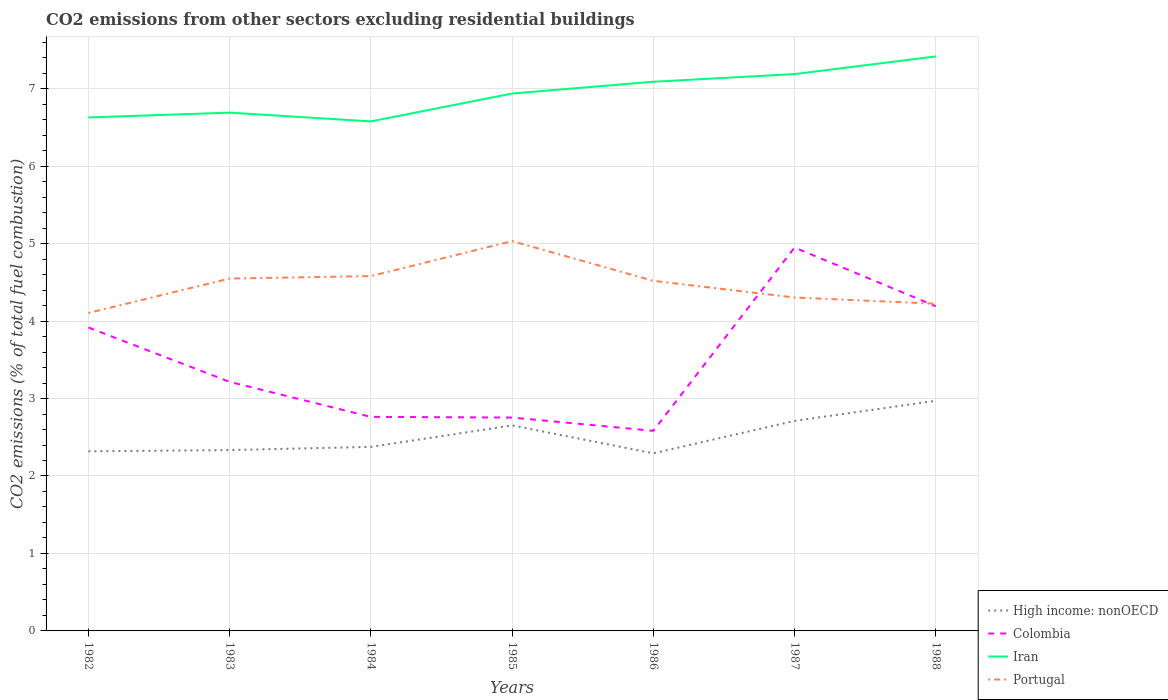How many different coloured lines are there?
Provide a short and direct response. 4. Across all years, what is the maximum total CO2 emitted in High income: nonOECD?
Provide a succinct answer. 2.29. What is the total total CO2 emitted in Colombia in the graph?
Your response must be concise. -1.44. What is the difference between the highest and the second highest total CO2 emitted in Portugal?
Your answer should be very brief. 0.93. Is the total CO2 emitted in Portugal strictly greater than the total CO2 emitted in High income: nonOECD over the years?
Provide a short and direct response. No. How many years are there in the graph?
Provide a succinct answer. 7. What is the difference between two consecutive major ticks on the Y-axis?
Give a very brief answer. 1. Are the values on the major ticks of Y-axis written in scientific E-notation?
Your response must be concise. No. Does the graph contain any zero values?
Keep it short and to the point. No. Does the graph contain grids?
Your answer should be compact. Yes. Where does the legend appear in the graph?
Make the answer very short. Bottom right. How many legend labels are there?
Provide a succinct answer. 4. What is the title of the graph?
Ensure brevity in your answer.  CO2 emissions from other sectors excluding residential buildings. What is the label or title of the Y-axis?
Provide a succinct answer. CO2 emissions (% of total fuel combustion). What is the CO2 emissions (% of total fuel combustion) of High income: nonOECD in 1982?
Keep it short and to the point. 2.32. What is the CO2 emissions (% of total fuel combustion) of Colombia in 1982?
Ensure brevity in your answer.  3.92. What is the CO2 emissions (% of total fuel combustion) in Iran in 1982?
Your response must be concise. 6.63. What is the CO2 emissions (% of total fuel combustion) in Portugal in 1982?
Your answer should be compact. 4.1. What is the CO2 emissions (% of total fuel combustion) in High income: nonOECD in 1983?
Your response must be concise. 2.33. What is the CO2 emissions (% of total fuel combustion) of Colombia in 1983?
Offer a terse response. 3.22. What is the CO2 emissions (% of total fuel combustion) in Iran in 1983?
Provide a succinct answer. 6.69. What is the CO2 emissions (% of total fuel combustion) of Portugal in 1983?
Your response must be concise. 4.55. What is the CO2 emissions (% of total fuel combustion) in High income: nonOECD in 1984?
Ensure brevity in your answer.  2.38. What is the CO2 emissions (% of total fuel combustion) of Colombia in 1984?
Ensure brevity in your answer.  2.76. What is the CO2 emissions (% of total fuel combustion) in Iran in 1984?
Provide a succinct answer. 6.58. What is the CO2 emissions (% of total fuel combustion) of Portugal in 1984?
Provide a short and direct response. 4.58. What is the CO2 emissions (% of total fuel combustion) in High income: nonOECD in 1985?
Your response must be concise. 2.65. What is the CO2 emissions (% of total fuel combustion) of Colombia in 1985?
Ensure brevity in your answer.  2.75. What is the CO2 emissions (% of total fuel combustion) of Iran in 1985?
Your response must be concise. 6.94. What is the CO2 emissions (% of total fuel combustion) in Portugal in 1985?
Make the answer very short. 5.03. What is the CO2 emissions (% of total fuel combustion) of High income: nonOECD in 1986?
Your answer should be compact. 2.29. What is the CO2 emissions (% of total fuel combustion) in Colombia in 1986?
Provide a short and direct response. 2.58. What is the CO2 emissions (% of total fuel combustion) in Iran in 1986?
Make the answer very short. 7.09. What is the CO2 emissions (% of total fuel combustion) in Portugal in 1986?
Offer a very short reply. 4.52. What is the CO2 emissions (% of total fuel combustion) in High income: nonOECD in 1987?
Offer a terse response. 2.71. What is the CO2 emissions (% of total fuel combustion) of Colombia in 1987?
Make the answer very short. 4.95. What is the CO2 emissions (% of total fuel combustion) in Iran in 1987?
Provide a succinct answer. 7.19. What is the CO2 emissions (% of total fuel combustion) of Portugal in 1987?
Give a very brief answer. 4.3. What is the CO2 emissions (% of total fuel combustion) of High income: nonOECD in 1988?
Your answer should be very brief. 2.97. What is the CO2 emissions (% of total fuel combustion) in Colombia in 1988?
Your answer should be compact. 4.19. What is the CO2 emissions (% of total fuel combustion) of Iran in 1988?
Your response must be concise. 7.42. What is the CO2 emissions (% of total fuel combustion) of Portugal in 1988?
Keep it short and to the point. 4.22. Across all years, what is the maximum CO2 emissions (% of total fuel combustion) in High income: nonOECD?
Make the answer very short. 2.97. Across all years, what is the maximum CO2 emissions (% of total fuel combustion) in Colombia?
Your answer should be compact. 4.95. Across all years, what is the maximum CO2 emissions (% of total fuel combustion) of Iran?
Your answer should be very brief. 7.42. Across all years, what is the maximum CO2 emissions (% of total fuel combustion) in Portugal?
Provide a short and direct response. 5.03. Across all years, what is the minimum CO2 emissions (% of total fuel combustion) of High income: nonOECD?
Your answer should be compact. 2.29. Across all years, what is the minimum CO2 emissions (% of total fuel combustion) of Colombia?
Your answer should be compact. 2.58. Across all years, what is the minimum CO2 emissions (% of total fuel combustion) of Iran?
Give a very brief answer. 6.58. Across all years, what is the minimum CO2 emissions (% of total fuel combustion) in Portugal?
Ensure brevity in your answer.  4.1. What is the total CO2 emissions (% of total fuel combustion) in High income: nonOECD in the graph?
Provide a short and direct response. 17.66. What is the total CO2 emissions (% of total fuel combustion) of Colombia in the graph?
Offer a very short reply. 24.37. What is the total CO2 emissions (% of total fuel combustion) of Iran in the graph?
Provide a succinct answer. 48.53. What is the total CO2 emissions (% of total fuel combustion) in Portugal in the graph?
Your response must be concise. 31.32. What is the difference between the CO2 emissions (% of total fuel combustion) of High income: nonOECD in 1982 and that in 1983?
Provide a succinct answer. -0.02. What is the difference between the CO2 emissions (% of total fuel combustion) of Colombia in 1982 and that in 1983?
Your answer should be very brief. 0.7. What is the difference between the CO2 emissions (% of total fuel combustion) in Iran in 1982 and that in 1983?
Provide a short and direct response. -0.06. What is the difference between the CO2 emissions (% of total fuel combustion) in Portugal in 1982 and that in 1983?
Provide a succinct answer. -0.44. What is the difference between the CO2 emissions (% of total fuel combustion) of High income: nonOECD in 1982 and that in 1984?
Offer a very short reply. -0.06. What is the difference between the CO2 emissions (% of total fuel combustion) of Colombia in 1982 and that in 1984?
Provide a short and direct response. 1.15. What is the difference between the CO2 emissions (% of total fuel combustion) of Iran in 1982 and that in 1984?
Your response must be concise. 0.05. What is the difference between the CO2 emissions (% of total fuel combustion) of Portugal in 1982 and that in 1984?
Your response must be concise. -0.48. What is the difference between the CO2 emissions (% of total fuel combustion) of High income: nonOECD in 1982 and that in 1985?
Your response must be concise. -0.33. What is the difference between the CO2 emissions (% of total fuel combustion) of Colombia in 1982 and that in 1985?
Your answer should be very brief. 1.16. What is the difference between the CO2 emissions (% of total fuel combustion) of Iran in 1982 and that in 1985?
Make the answer very short. -0.31. What is the difference between the CO2 emissions (% of total fuel combustion) in Portugal in 1982 and that in 1985?
Your answer should be compact. -0.93. What is the difference between the CO2 emissions (% of total fuel combustion) in High income: nonOECD in 1982 and that in 1986?
Your answer should be very brief. 0.03. What is the difference between the CO2 emissions (% of total fuel combustion) in Colombia in 1982 and that in 1986?
Provide a short and direct response. 1.33. What is the difference between the CO2 emissions (% of total fuel combustion) in Iran in 1982 and that in 1986?
Give a very brief answer. -0.46. What is the difference between the CO2 emissions (% of total fuel combustion) in Portugal in 1982 and that in 1986?
Offer a very short reply. -0.41. What is the difference between the CO2 emissions (% of total fuel combustion) of High income: nonOECD in 1982 and that in 1987?
Your answer should be compact. -0.39. What is the difference between the CO2 emissions (% of total fuel combustion) in Colombia in 1982 and that in 1987?
Offer a terse response. -1.03. What is the difference between the CO2 emissions (% of total fuel combustion) in Iran in 1982 and that in 1987?
Your response must be concise. -0.56. What is the difference between the CO2 emissions (% of total fuel combustion) in Portugal in 1982 and that in 1987?
Your response must be concise. -0.2. What is the difference between the CO2 emissions (% of total fuel combustion) in High income: nonOECD in 1982 and that in 1988?
Your answer should be compact. -0.65. What is the difference between the CO2 emissions (% of total fuel combustion) in Colombia in 1982 and that in 1988?
Ensure brevity in your answer.  -0.27. What is the difference between the CO2 emissions (% of total fuel combustion) of Iran in 1982 and that in 1988?
Offer a terse response. -0.79. What is the difference between the CO2 emissions (% of total fuel combustion) of Portugal in 1982 and that in 1988?
Your answer should be compact. -0.12. What is the difference between the CO2 emissions (% of total fuel combustion) in High income: nonOECD in 1983 and that in 1984?
Your response must be concise. -0.04. What is the difference between the CO2 emissions (% of total fuel combustion) in Colombia in 1983 and that in 1984?
Offer a terse response. 0.45. What is the difference between the CO2 emissions (% of total fuel combustion) in Iran in 1983 and that in 1984?
Your answer should be very brief. 0.11. What is the difference between the CO2 emissions (% of total fuel combustion) of Portugal in 1983 and that in 1984?
Make the answer very short. -0.03. What is the difference between the CO2 emissions (% of total fuel combustion) in High income: nonOECD in 1983 and that in 1985?
Your answer should be compact. -0.32. What is the difference between the CO2 emissions (% of total fuel combustion) of Colombia in 1983 and that in 1985?
Offer a very short reply. 0.46. What is the difference between the CO2 emissions (% of total fuel combustion) of Iran in 1983 and that in 1985?
Your answer should be very brief. -0.25. What is the difference between the CO2 emissions (% of total fuel combustion) of Portugal in 1983 and that in 1985?
Your answer should be compact. -0.48. What is the difference between the CO2 emissions (% of total fuel combustion) of High income: nonOECD in 1983 and that in 1986?
Offer a terse response. 0.04. What is the difference between the CO2 emissions (% of total fuel combustion) in Colombia in 1983 and that in 1986?
Your response must be concise. 0.63. What is the difference between the CO2 emissions (% of total fuel combustion) in Iran in 1983 and that in 1986?
Make the answer very short. -0.4. What is the difference between the CO2 emissions (% of total fuel combustion) of Portugal in 1983 and that in 1986?
Your response must be concise. 0.03. What is the difference between the CO2 emissions (% of total fuel combustion) in High income: nonOECD in 1983 and that in 1987?
Your response must be concise. -0.38. What is the difference between the CO2 emissions (% of total fuel combustion) of Colombia in 1983 and that in 1987?
Give a very brief answer. -1.73. What is the difference between the CO2 emissions (% of total fuel combustion) of Iran in 1983 and that in 1987?
Keep it short and to the point. -0.5. What is the difference between the CO2 emissions (% of total fuel combustion) in Portugal in 1983 and that in 1987?
Provide a succinct answer. 0.24. What is the difference between the CO2 emissions (% of total fuel combustion) of High income: nonOECD in 1983 and that in 1988?
Provide a succinct answer. -0.64. What is the difference between the CO2 emissions (% of total fuel combustion) of Colombia in 1983 and that in 1988?
Offer a very short reply. -0.98. What is the difference between the CO2 emissions (% of total fuel combustion) in Iran in 1983 and that in 1988?
Ensure brevity in your answer.  -0.73. What is the difference between the CO2 emissions (% of total fuel combustion) of Portugal in 1983 and that in 1988?
Offer a very short reply. 0.32. What is the difference between the CO2 emissions (% of total fuel combustion) of High income: nonOECD in 1984 and that in 1985?
Your response must be concise. -0.28. What is the difference between the CO2 emissions (% of total fuel combustion) of Colombia in 1984 and that in 1985?
Your answer should be very brief. 0.01. What is the difference between the CO2 emissions (% of total fuel combustion) in Iran in 1984 and that in 1985?
Your response must be concise. -0.36. What is the difference between the CO2 emissions (% of total fuel combustion) in Portugal in 1984 and that in 1985?
Ensure brevity in your answer.  -0.45. What is the difference between the CO2 emissions (% of total fuel combustion) of High income: nonOECD in 1984 and that in 1986?
Offer a very short reply. 0.08. What is the difference between the CO2 emissions (% of total fuel combustion) of Colombia in 1984 and that in 1986?
Your response must be concise. 0.18. What is the difference between the CO2 emissions (% of total fuel combustion) in Iran in 1984 and that in 1986?
Give a very brief answer. -0.51. What is the difference between the CO2 emissions (% of total fuel combustion) in Portugal in 1984 and that in 1986?
Provide a short and direct response. 0.06. What is the difference between the CO2 emissions (% of total fuel combustion) of High income: nonOECD in 1984 and that in 1987?
Provide a succinct answer. -0.34. What is the difference between the CO2 emissions (% of total fuel combustion) in Colombia in 1984 and that in 1987?
Offer a very short reply. -2.19. What is the difference between the CO2 emissions (% of total fuel combustion) in Iran in 1984 and that in 1987?
Your answer should be compact. -0.61. What is the difference between the CO2 emissions (% of total fuel combustion) in Portugal in 1984 and that in 1987?
Offer a very short reply. 0.28. What is the difference between the CO2 emissions (% of total fuel combustion) of High income: nonOECD in 1984 and that in 1988?
Make the answer very short. -0.59. What is the difference between the CO2 emissions (% of total fuel combustion) of Colombia in 1984 and that in 1988?
Your response must be concise. -1.43. What is the difference between the CO2 emissions (% of total fuel combustion) in Iran in 1984 and that in 1988?
Offer a very short reply. -0.84. What is the difference between the CO2 emissions (% of total fuel combustion) in Portugal in 1984 and that in 1988?
Give a very brief answer. 0.36. What is the difference between the CO2 emissions (% of total fuel combustion) in High income: nonOECD in 1985 and that in 1986?
Provide a short and direct response. 0.36. What is the difference between the CO2 emissions (% of total fuel combustion) in Colombia in 1985 and that in 1986?
Ensure brevity in your answer.  0.17. What is the difference between the CO2 emissions (% of total fuel combustion) of Iran in 1985 and that in 1986?
Ensure brevity in your answer.  -0.15. What is the difference between the CO2 emissions (% of total fuel combustion) of Portugal in 1985 and that in 1986?
Your response must be concise. 0.51. What is the difference between the CO2 emissions (% of total fuel combustion) in High income: nonOECD in 1985 and that in 1987?
Ensure brevity in your answer.  -0.06. What is the difference between the CO2 emissions (% of total fuel combustion) in Colombia in 1985 and that in 1987?
Your response must be concise. -2.19. What is the difference between the CO2 emissions (% of total fuel combustion) in Iran in 1985 and that in 1987?
Your response must be concise. -0.25. What is the difference between the CO2 emissions (% of total fuel combustion) in Portugal in 1985 and that in 1987?
Offer a very short reply. 0.73. What is the difference between the CO2 emissions (% of total fuel combustion) in High income: nonOECD in 1985 and that in 1988?
Make the answer very short. -0.32. What is the difference between the CO2 emissions (% of total fuel combustion) of Colombia in 1985 and that in 1988?
Your answer should be compact. -1.44. What is the difference between the CO2 emissions (% of total fuel combustion) of Iran in 1985 and that in 1988?
Provide a short and direct response. -0.48. What is the difference between the CO2 emissions (% of total fuel combustion) of Portugal in 1985 and that in 1988?
Provide a succinct answer. 0.81. What is the difference between the CO2 emissions (% of total fuel combustion) of High income: nonOECD in 1986 and that in 1987?
Provide a succinct answer. -0.42. What is the difference between the CO2 emissions (% of total fuel combustion) of Colombia in 1986 and that in 1987?
Make the answer very short. -2.37. What is the difference between the CO2 emissions (% of total fuel combustion) in Iran in 1986 and that in 1987?
Make the answer very short. -0.1. What is the difference between the CO2 emissions (% of total fuel combustion) of Portugal in 1986 and that in 1987?
Your answer should be very brief. 0.22. What is the difference between the CO2 emissions (% of total fuel combustion) in High income: nonOECD in 1986 and that in 1988?
Make the answer very short. -0.68. What is the difference between the CO2 emissions (% of total fuel combustion) of Colombia in 1986 and that in 1988?
Make the answer very short. -1.61. What is the difference between the CO2 emissions (% of total fuel combustion) of Iran in 1986 and that in 1988?
Your answer should be very brief. -0.33. What is the difference between the CO2 emissions (% of total fuel combustion) of Portugal in 1986 and that in 1988?
Give a very brief answer. 0.3. What is the difference between the CO2 emissions (% of total fuel combustion) in High income: nonOECD in 1987 and that in 1988?
Give a very brief answer. -0.26. What is the difference between the CO2 emissions (% of total fuel combustion) in Colombia in 1987 and that in 1988?
Offer a terse response. 0.76. What is the difference between the CO2 emissions (% of total fuel combustion) of Iran in 1987 and that in 1988?
Offer a very short reply. -0.23. What is the difference between the CO2 emissions (% of total fuel combustion) of Portugal in 1987 and that in 1988?
Offer a very short reply. 0.08. What is the difference between the CO2 emissions (% of total fuel combustion) of High income: nonOECD in 1982 and the CO2 emissions (% of total fuel combustion) of Colombia in 1983?
Ensure brevity in your answer.  -0.9. What is the difference between the CO2 emissions (% of total fuel combustion) in High income: nonOECD in 1982 and the CO2 emissions (% of total fuel combustion) in Iran in 1983?
Your answer should be very brief. -4.37. What is the difference between the CO2 emissions (% of total fuel combustion) of High income: nonOECD in 1982 and the CO2 emissions (% of total fuel combustion) of Portugal in 1983?
Provide a succinct answer. -2.23. What is the difference between the CO2 emissions (% of total fuel combustion) in Colombia in 1982 and the CO2 emissions (% of total fuel combustion) in Iran in 1983?
Offer a terse response. -2.77. What is the difference between the CO2 emissions (% of total fuel combustion) of Colombia in 1982 and the CO2 emissions (% of total fuel combustion) of Portugal in 1983?
Keep it short and to the point. -0.63. What is the difference between the CO2 emissions (% of total fuel combustion) of Iran in 1982 and the CO2 emissions (% of total fuel combustion) of Portugal in 1983?
Your answer should be very brief. 2.08. What is the difference between the CO2 emissions (% of total fuel combustion) in High income: nonOECD in 1982 and the CO2 emissions (% of total fuel combustion) in Colombia in 1984?
Your response must be concise. -0.44. What is the difference between the CO2 emissions (% of total fuel combustion) of High income: nonOECD in 1982 and the CO2 emissions (% of total fuel combustion) of Iran in 1984?
Your response must be concise. -4.26. What is the difference between the CO2 emissions (% of total fuel combustion) in High income: nonOECD in 1982 and the CO2 emissions (% of total fuel combustion) in Portugal in 1984?
Your answer should be compact. -2.26. What is the difference between the CO2 emissions (% of total fuel combustion) in Colombia in 1982 and the CO2 emissions (% of total fuel combustion) in Iran in 1984?
Offer a terse response. -2.66. What is the difference between the CO2 emissions (% of total fuel combustion) of Colombia in 1982 and the CO2 emissions (% of total fuel combustion) of Portugal in 1984?
Offer a terse response. -0.66. What is the difference between the CO2 emissions (% of total fuel combustion) of Iran in 1982 and the CO2 emissions (% of total fuel combustion) of Portugal in 1984?
Give a very brief answer. 2.05. What is the difference between the CO2 emissions (% of total fuel combustion) of High income: nonOECD in 1982 and the CO2 emissions (% of total fuel combustion) of Colombia in 1985?
Your answer should be compact. -0.44. What is the difference between the CO2 emissions (% of total fuel combustion) of High income: nonOECD in 1982 and the CO2 emissions (% of total fuel combustion) of Iran in 1985?
Keep it short and to the point. -4.62. What is the difference between the CO2 emissions (% of total fuel combustion) in High income: nonOECD in 1982 and the CO2 emissions (% of total fuel combustion) in Portugal in 1985?
Your answer should be very brief. -2.71. What is the difference between the CO2 emissions (% of total fuel combustion) in Colombia in 1982 and the CO2 emissions (% of total fuel combustion) in Iran in 1985?
Provide a succinct answer. -3.02. What is the difference between the CO2 emissions (% of total fuel combustion) of Colombia in 1982 and the CO2 emissions (% of total fuel combustion) of Portugal in 1985?
Your answer should be compact. -1.12. What is the difference between the CO2 emissions (% of total fuel combustion) of Iran in 1982 and the CO2 emissions (% of total fuel combustion) of Portugal in 1985?
Your answer should be very brief. 1.6. What is the difference between the CO2 emissions (% of total fuel combustion) in High income: nonOECD in 1982 and the CO2 emissions (% of total fuel combustion) in Colombia in 1986?
Ensure brevity in your answer.  -0.26. What is the difference between the CO2 emissions (% of total fuel combustion) in High income: nonOECD in 1982 and the CO2 emissions (% of total fuel combustion) in Iran in 1986?
Make the answer very short. -4.77. What is the difference between the CO2 emissions (% of total fuel combustion) of High income: nonOECD in 1982 and the CO2 emissions (% of total fuel combustion) of Portugal in 1986?
Your answer should be compact. -2.2. What is the difference between the CO2 emissions (% of total fuel combustion) of Colombia in 1982 and the CO2 emissions (% of total fuel combustion) of Iran in 1986?
Provide a short and direct response. -3.17. What is the difference between the CO2 emissions (% of total fuel combustion) in Colombia in 1982 and the CO2 emissions (% of total fuel combustion) in Portugal in 1986?
Provide a succinct answer. -0.6. What is the difference between the CO2 emissions (% of total fuel combustion) in Iran in 1982 and the CO2 emissions (% of total fuel combustion) in Portugal in 1986?
Your answer should be very brief. 2.11. What is the difference between the CO2 emissions (% of total fuel combustion) of High income: nonOECD in 1982 and the CO2 emissions (% of total fuel combustion) of Colombia in 1987?
Offer a very short reply. -2.63. What is the difference between the CO2 emissions (% of total fuel combustion) in High income: nonOECD in 1982 and the CO2 emissions (% of total fuel combustion) in Iran in 1987?
Make the answer very short. -4.87. What is the difference between the CO2 emissions (% of total fuel combustion) of High income: nonOECD in 1982 and the CO2 emissions (% of total fuel combustion) of Portugal in 1987?
Your response must be concise. -1.99. What is the difference between the CO2 emissions (% of total fuel combustion) in Colombia in 1982 and the CO2 emissions (% of total fuel combustion) in Iran in 1987?
Keep it short and to the point. -3.27. What is the difference between the CO2 emissions (% of total fuel combustion) in Colombia in 1982 and the CO2 emissions (% of total fuel combustion) in Portugal in 1987?
Your response must be concise. -0.39. What is the difference between the CO2 emissions (% of total fuel combustion) in Iran in 1982 and the CO2 emissions (% of total fuel combustion) in Portugal in 1987?
Ensure brevity in your answer.  2.32. What is the difference between the CO2 emissions (% of total fuel combustion) of High income: nonOECD in 1982 and the CO2 emissions (% of total fuel combustion) of Colombia in 1988?
Provide a succinct answer. -1.87. What is the difference between the CO2 emissions (% of total fuel combustion) of High income: nonOECD in 1982 and the CO2 emissions (% of total fuel combustion) of Iran in 1988?
Your answer should be very brief. -5.1. What is the difference between the CO2 emissions (% of total fuel combustion) of High income: nonOECD in 1982 and the CO2 emissions (% of total fuel combustion) of Portugal in 1988?
Offer a terse response. -1.91. What is the difference between the CO2 emissions (% of total fuel combustion) of Colombia in 1982 and the CO2 emissions (% of total fuel combustion) of Iran in 1988?
Your response must be concise. -3.5. What is the difference between the CO2 emissions (% of total fuel combustion) in Colombia in 1982 and the CO2 emissions (% of total fuel combustion) in Portugal in 1988?
Offer a terse response. -0.31. What is the difference between the CO2 emissions (% of total fuel combustion) in Iran in 1982 and the CO2 emissions (% of total fuel combustion) in Portugal in 1988?
Provide a short and direct response. 2.4. What is the difference between the CO2 emissions (% of total fuel combustion) in High income: nonOECD in 1983 and the CO2 emissions (% of total fuel combustion) in Colombia in 1984?
Provide a succinct answer. -0.43. What is the difference between the CO2 emissions (% of total fuel combustion) of High income: nonOECD in 1983 and the CO2 emissions (% of total fuel combustion) of Iran in 1984?
Ensure brevity in your answer.  -4.24. What is the difference between the CO2 emissions (% of total fuel combustion) of High income: nonOECD in 1983 and the CO2 emissions (% of total fuel combustion) of Portugal in 1984?
Provide a short and direct response. -2.25. What is the difference between the CO2 emissions (% of total fuel combustion) of Colombia in 1983 and the CO2 emissions (% of total fuel combustion) of Iran in 1984?
Offer a very short reply. -3.36. What is the difference between the CO2 emissions (% of total fuel combustion) of Colombia in 1983 and the CO2 emissions (% of total fuel combustion) of Portugal in 1984?
Provide a short and direct response. -1.37. What is the difference between the CO2 emissions (% of total fuel combustion) in Iran in 1983 and the CO2 emissions (% of total fuel combustion) in Portugal in 1984?
Keep it short and to the point. 2.11. What is the difference between the CO2 emissions (% of total fuel combustion) in High income: nonOECD in 1983 and the CO2 emissions (% of total fuel combustion) in Colombia in 1985?
Your response must be concise. -0.42. What is the difference between the CO2 emissions (% of total fuel combustion) in High income: nonOECD in 1983 and the CO2 emissions (% of total fuel combustion) in Iran in 1985?
Make the answer very short. -4.6. What is the difference between the CO2 emissions (% of total fuel combustion) of High income: nonOECD in 1983 and the CO2 emissions (% of total fuel combustion) of Portugal in 1985?
Make the answer very short. -2.7. What is the difference between the CO2 emissions (% of total fuel combustion) of Colombia in 1983 and the CO2 emissions (% of total fuel combustion) of Iran in 1985?
Provide a succinct answer. -3.72. What is the difference between the CO2 emissions (% of total fuel combustion) of Colombia in 1983 and the CO2 emissions (% of total fuel combustion) of Portugal in 1985?
Give a very brief answer. -1.82. What is the difference between the CO2 emissions (% of total fuel combustion) in Iran in 1983 and the CO2 emissions (% of total fuel combustion) in Portugal in 1985?
Keep it short and to the point. 1.66. What is the difference between the CO2 emissions (% of total fuel combustion) in High income: nonOECD in 1983 and the CO2 emissions (% of total fuel combustion) in Colombia in 1986?
Ensure brevity in your answer.  -0.25. What is the difference between the CO2 emissions (% of total fuel combustion) in High income: nonOECD in 1983 and the CO2 emissions (% of total fuel combustion) in Iran in 1986?
Your answer should be very brief. -4.76. What is the difference between the CO2 emissions (% of total fuel combustion) in High income: nonOECD in 1983 and the CO2 emissions (% of total fuel combustion) in Portugal in 1986?
Your answer should be compact. -2.19. What is the difference between the CO2 emissions (% of total fuel combustion) of Colombia in 1983 and the CO2 emissions (% of total fuel combustion) of Iran in 1986?
Give a very brief answer. -3.87. What is the difference between the CO2 emissions (% of total fuel combustion) of Colombia in 1983 and the CO2 emissions (% of total fuel combustion) of Portugal in 1986?
Offer a very short reply. -1.3. What is the difference between the CO2 emissions (% of total fuel combustion) of Iran in 1983 and the CO2 emissions (% of total fuel combustion) of Portugal in 1986?
Your answer should be very brief. 2.17. What is the difference between the CO2 emissions (% of total fuel combustion) in High income: nonOECD in 1983 and the CO2 emissions (% of total fuel combustion) in Colombia in 1987?
Your response must be concise. -2.62. What is the difference between the CO2 emissions (% of total fuel combustion) in High income: nonOECD in 1983 and the CO2 emissions (% of total fuel combustion) in Iran in 1987?
Make the answer very short. -4.85. What is the difference between the CO2 emissions (% of total fuel combustion) in High income: nonOECD in 1983 and the CO2 emissions (% of total fuel combustion) in Portugal in 1987?
Make the answer very short. -1.97. What is the difference between the CO2 emissions (% of total fuel combustion) in Colombia in 1983 and the CO2 emissions (% of total fuel combustion) in Iran in 1987?
Your response must be concise. -3.97. What is the difference between the CO2 emissions (% of total fuel combustion) in Colombia in 1983 and the CO2 emissions (% of total fuel combustion) in Portugal in 1987?
Your response must be concise. -1.09. What is the difference between the CO2 emissions (% of total fuel combustion) of Iran in 1983 and the CO2 emissions (% of total fuel combustion) of Portugal in 1987?
Offer a terse response. 2.39. What is the difference between the CO2 emissions (% of total fuel combustion) in High income: nonOECD in 1983 and the CO2 emissions (% of total fuel combustion) in Colombia in 1988?
Make the answer very short. -1.86. What is the difference between the CO2 emissions (% of total fuel combustion) of High income: nonOECD in 1983 and the CO2 emissions (% of total fuel combustion) of Iran in 1988?
Provide a succinct answer. -5.08. What is the difference between the CO2 emissions (% of total fuel combustion) of High income: nonOECD in 1983 and the CO2 emissions (% of total fuel combustion) of Portugal in 1988?
Offer a terse response. -1.89. What is the difference between the CO2 emissions (% of total fuel combustion) in Colombia in 1983 and the CO2 emissions (% of total fuel combustion) in Iran in 1988?
Offer a very short reply. -4.2. What is the difference between the CO2 emissions (% of total fuel combustion) in Colombia in 1983 and the CO2 emissions (% of total fuel combustion) in Portugal in 1988?
Keep it short and to the point. -1.01. What is the difference between the CO2 emissions (% of total fuel combustion) of Iran in 1983 and the CO2 emissions (% of total fuel combustion) of Portugal in 1988?
Provide a succinct answer. 2.47. What is the difference between the CO2 emissions (% of total fuel combustion) of High income: nonOECD in 1984 and the CO2 emissions (% of total fuel combustion) of Colombia in 1985?
Your response must be concise. -0.38. What is the difference between the CO2 emissions (% of total fuel combustion) of High income: nonOECD in 1984 and the CO2 emissions (% of total fuel combustion) of Iran in 1985?
Offer a terse response. -4.56. What is the difference between the CO2 emissions (% of total fuel combustion) of High income: nonOECD in 1984 and the CO2 emissions (% of total fuel combustion) of Portugal in 1985?
Give a very brief answer. -2.66. What is the difference between the CO2 emissions (% of total fuel combustion) of Colombia in 1984 and the CO2 emissions (% of total fuel combustion) of Iran in 1985?
Your response must be concise. -4.17. What is the difference between the CO2 emissions (% of total fuel combustion) in Colombia in 1984 and the CO2 emissions (% of total fuel combustion) in Portugal in 1985?
Your answer should be very brief. -2.27. What is the difference between the CO2 emissions (% of total fuel combustion) of Iran in 1984 and the CO2 emissions (% of total fuel combustion) of Portugal in 1985?
Offer a terse response. 1.55. What is the difference between the CO2 emissions (% of total fuel combustion) in High income: nonOECD in 1984 and the CO2 emissions (% of total fuel combustion) in Colombia in 1986?
Your response must be concise. -0.21. What is the difference between the CO2 emissions (% of total fuel combustion) in High income: nonOECD in 1984 and the CO2 emissions (% of total fuel combustion) in Iran in 1986?
Provide a short and direct response. -4.71. What is the difference between the CO2 emissions (% of total fuel combustion) in High income: nonOECD in 1984 and the CO2 emissions (% of total fuel combustion) in Portugal in 1986?
Give a very brief answer. -2.14. What is the difference between the CO2 emissions (% of total fuel combustion) in Colombia in 1984 and the CO2 emissions (% of total fuel combustion) in Iran in 1986?
Ensure brevity in your answer.  -4.33. What is the difference between the CO2 emissions (% of total fuel combustion) in Colombia in 1984 and the CO2 emissions (% of total fuel combustion) in Portugal in 1986?
Make the answer very short. -1.76. What is the difference between the CO2 emissions (% of total fuel combustion) of Iran in 1984 and the CO2 emissions (% of total fuel combustion) of Portugal in 1986?
Your answer should be very brief. 2.06. What is the difference between the CO2 emissions (% of total fuel combustion) in High income: nonOECD in 1984 and the CO2 emissions (% of total fuel combustion) in Colombia in 1987?
Your answer should be very brief. -2.57. What is the difference between the CO2 emissions (% of total fuel combustion) of High income: nonOECD in 1984 and the CO2 emissions (% of total fuel combustion) of Iran in 1987?
Your response must be concise. -4.81. What is the difference between the CO2 emissions (% of total fuel combustion) of High income: nonOECD in 1984 and the CO2 emissions (% of total fuel combustion) of Portugal in 1987?
Provide a succinct answer. -1.93. What is the difference between the CO2 emissions (% of total fuel combustion) of Colombia in 1984 and the CO2 emissions (% of total fuel combustion) of Iran in 1987?
Your response must be concise. -4.43. What is the difference between the CO2 emissions (% of total fuel combustion) of Colombia in 1984 and the CO2 emissions (% of total fuel combustion) of Portugal in 1987?
Keep it short and to the point. -1.54. What is the difference between the CO2 emissions (% of total fuel combustion) of Iran in 1984 and the CO2 emissions (% of total fuel combustion) of Portugal in 1987?
Your response must be concise. 2.27. What is the difference between the CO2 emissions (% of total fuel combustion) of High income: nonOECD in 1984 and the CO2 emissions (% of total fuel combustion) of Colombia in 1988?
Keep it short and to the point. -1.82. What is the difference between the CO2 emissions (% of total fuel combustion) in High income: nonOECD in 1984 and the CO2 emissions (% of total fuel combustion) in Iran in 1988?
Your answer should be compact. -5.04. What is the difference between the CO2 emissions (% of total fuel combustion) of High income: nonOECD in 1984 and the CO2 emissions (% of total fuel combustion) of Portugal in 1988?
Your answer should be very brief. -1.85. What is the difference between the CO2 emissions (% of total fuel combustion) of Colombia in 1984 and the CO2 emissions (% of total fuel combustion) of Iran in 1988?
Offer a terse response. -4.65. What is the difference between the CO2 emissions (% of total fuel combustion) of Colombia in 1984 and the CO2 emissions (% of total fuel combustion) of Portugal in 1988?
Offer a very short reply. -1.46. What is the difference between the CO2 emissions (% of total fuel combustion) of Iran in 1984 and the CO2 emissions (% of total fuel combustion) of Portugal in 1988?
Your answer should be very brief. 2.35. What is the difference between the CO2 emissions (% of total fuel combustion) in High income: nonOECD in 1985 and the CO2 emissions (% of total fuel combustion) in Colombia in 1986?
Ensure brevity in your answer.  0.07. What is the difference between the CO2 emissions (% of total fuel combustion) of High income: nonOECD in 1985 and the CO2 emissions (% of total fuel combustion) of Iran in 1986?
Provide a short and direct response. -4.44. What is the difference between the CO2 emissions (% of total fuel combustion) of High income: nonOECD in 1985 and the CO2 emissions (% of total fuel combustion) of Portugal in 1986?
Your response must be concise. -1.87. What is the difference between the CO2 emissions (% of total fuel combustion) in Colombia in 1985 and the CO2 emissions (% of total fuel combustion) in Iran in 1986?
Offer a very short reply. -4.34. What is the difference between the CO2 emissions (% of total fuel combustion) of Colombia in 1985 and the CO2 emissions (% of total fuel combustion) of Portugal in 1986?
Keep it short and to the point. -1.76. What is the difference between the CO2 emissions (% of total fuel combustion) in Iran in 1985 and the CO2 emissions (% of total fuel combustion) in Portugal in 1986?
Ensure brevity in your answer.  2.42. What is the difference between the CO2 emissions (% of total fuel combustion) in High income: nonOECD in 1985 and the CO2 emissions (% of total fuel combustion) in Colombia in 1987?
Offer a very short reply. -2.3. What is the difference between the CO2 emissions (% of total fuel combustion) in High income: nonOECD in 1985 and the CO2 emissions (% of total fuel combustion) in Iran in 1987?
Offer a very short reply. -4.54. What is the difference between the CO2 emissions (% of total fuel combustion) of High income: nonOECD in 1985 and the CO2 emissions (% of total fuel combustion) of Portugal in 1987?
Your answer should be compact. -1.65. What is the difference between the CO2 emissions (% of total fuel combustion) of Colombia in 1985 and the CO2 emissions (% of total fuel combustion) of Iran in 1987?
Offer a very short reply. -4.43. What is the difference between the CO2 emissions (% of total fuel combustion) of Colombia in 1985 and the CO2 emissions (% of total fuel combustion) of Portugal in 1987?
Make the answer very short. -1.55. What is the difference between the CO2 emissions (% of total fuel combustion) in Iran in 1985 and the CO2 emissions (% of total fuel combustion) in Portugal in 1987?
Ensure brevity in your answer.  2.63. What is the difference between the CO2 emissions (% of total fuel combustion) in High income: nonOECD in 1985 and the CO2 emissions (% of total fuel combustion) in Colombia in 1988?
Make the answer very short. -1.54. What is the difference between the CO2 emissions (% of total fuel combustion) in High income: nonOECD in 1985 and the CO2 emissions (% of total fuel combustion) in Iran in 1988?
Your response must be concise. -4.76. What is the difference between the CO2 emissions (% of total fuel combustion) in High income: nonOECD in 1985 and the CO2 emissions (% of total fuel combustion) in Portugal in 1988?
Your answer should be compact. -1.57. What is the difference between the CO2 emissions (% of total fuel combustion) of Colombia in 1985 and the CO2 emissions (% of total fuel combustion) of Iran in 1988?
Your response must be concise. -4.66. What is the difference between the CO2 emissions (% of total fuel combustion) in Colombia in 1985 and the CO2 emissions (% of total fuel combustion) in Portugal in 1988?
Your answer should be very brief. -1.47. What is the difference between the CO2 emissions (% of total fuel combustion) of Iran in 1985 and the CO2 emissions (% of total fuel combustion) of Portugal in 1988?
Provide a short and direct response. 2.71. What is the difference between the CO2 emissions (% of total fuel combustion) of High income: nonOECD in 1986 and the CO2 emissions (% of total fuel combustion) of Colombia in 1987?
Provide a succinct answer. -2.66. What is the difference between the CO2 emissions (% of total fuel combustion) of High income: nonOECD in 1986 and the CO2 emissions (% of total fuel combustion) of Iran in 1987?
Give a very brief answer. -4.9. What is the difference between the CO2 emissions (% of total fuel combustion) of High income: nonOECD in 1986 and the CO2 emissions (% of total fuel combustion) of Portugal in 1987?
Your answer should be compact. -2.01. What is the difference between the CO2 emissions (% of total fuel combustion) of Colombia in 1986 and the CO2 emissions (% of total fuel combustion) of Iran in 1987?
Provide a succinct answer. -4.61. What is the difference between the CO2 emissions (% of total fuel combustion) of Colombia in 1986 and the CO2 emissions (% of total fuel combustion) of Portugal in 1987?
Your response must be concise. -1.72. What is the difference between the CO2 emissions (% of total fuel combustion) in Iran in 1986 and the CO2 emissions (% of total fuel combustion) in Portugal in 1987?
Your answer should be compact. 2.79. What is the difference between the CO2 emissions (% of total fuel combustion) in High income: nonOECD in 1986 and the CO2 emissions (% of total fuel combustion) in Colombia in 1988?
Keep it short and to the point. -1.9. What is the difference between the CO2 emissions (% of total fuel combustion) of High income: nonOECD in 1986 and the CO2 emissions (% of total fuel combustion) of Iran in 1988?
Your answer should be very brief. -5.12. What is the difference between the CO2 emissions (% of total fuel combustion) of High income: nonOECD in 1986 and the CO2 emissions (% of total fuel combustion) of Portugal in 1988?
Your answer should be very brief. -1.93. What is the difference between the CO2 emissions (% of total fuel combustion) in Colombia in 1986 and the CO2 emissions (% of total fuel combustion) in Iran in 1988?
Provide a short and direct response. -4.83. What is the difference between the CO2 emissions (% of total fuel combustion) in Colombia in 1986 and the CO2 emissions (% of total fuel combustion) in Portugal in 1988?
Your answer should be compact. -1.64. What is the difference between the CO2 emissions (% of total fuel combustion) in Iran in 1986 and the CO2 emissions (% of total fuel combustion) in Portugal in 1988?
Your answer should be very brief. 2.87. What is the difference between the CO2 emissions (% of total fuel combustion) of High income: nonOECD in 1987 and the CO2 emissions (% of total fuel combustion) of Colombia in 1988?
Give a very brief answer. -1.48. What is the difference between the CO2 emissions (% of total fuel combustion) in High income: nonOECD in 1987 and the CO2 emissions (% of total fuel combustion) in Iran in 1988?
Give a very brief answer. -4.71. What is the difference between the CO2 emissions (% of total fuel combustion) of High income: nonOECD in 1987 and the CO2 emissions (% of total fuel combustion) of Portugal in 1988?
Provide a short and direct response. -1.51. What is the difference between the CO2 emissions (% of total fuel combustion) of Colombia in 1987 and the CO2 emissions (% of total fuel combustion) of Iran in 1988?
Provide a succinct answer. -2.47. What is the difference between the CO2 emissions (% of total fuel combustion) of Colombia in 1987 and the CO2 emissions (% of total fuel combustion) of Portugal in 1988?
Your answer should be compact. 0.73. What is the difference between the CO2 emissions (% of total fuel combustion) in Iran in 1987 and the CO2 emissions (% of total fuel combustion) in Portugal in 1988?
Your response must be concise. 2.96. What is the average CO2 emissions (% of total fuel combustion) in High income: nonOECD per year?
Your answer should be compact. 2.52. What is the average CO2 emissions (% of total fuel combustion) in Colombia per year?
Offer a terse response. 3.48. What is the average CO2 emissions (% of total fuel combustion) of Iran per year?
Provide a short and direct response. 6.93. What is the average CO2 emissions (% of total fuel combustion) in Portugal per year?
Your answer should be very brief. 4.47. In the year 1982, what is the difference between the CO2 emissions (% of total fuel combustion) in High income: nonOECD and CO2 emissions (% of total fuel combustion) in Colombia?
Provide a succinct answer. -1.6. In the year 1982, what is the difference between the CO2 emissions (% of total fuel combustion) of High income: nonOECD and CO2 emissions (% of total fuel combustion) of Iran?
Your response must be concise. -4.31. In the year 1982, what is the difference between the CO2 emissions (% of total fuel combustion) of High income: nonOECD and CO2 emissions (% of total fuel combustion) of Portugal?
Offer a terse response. -1.79. In the year 1982, what is the difference between the CO2 emissions (% of total fuel combustion) in Colombia and CO2 emissions (% of total fuel combustion) in Iran?
Keep it short and to the point. -2.71. In the year 1982, what is the difference between the CO2 emissions (% of total fuel combustion) of Colombia and CO2 emissions (% of total fuel combustion) of Portugal?
Keep it short and to the point. -0.19. In the year 1982, what is the difference between the CO2 emissions (% of total fuel combustion) of Iran and CO2 emissions (% of total fuel combustion) of Portugal?
Keep it short and to the point. 2.52. In the year 1983, what is the difference between the CO2 emissions (% of total fuel combustion) of High income: nonOECD and CO2 emissions (% of total fuel combustion) of Colombia?
Provide a succinct answer. -0.88. In the year 1983, what is the difference between the CO2 emissions (% of total fuel combustion) in High income: nonOECD and CO2 emissions (% of total fuel combustion) in Iran?
Offer a very short reply. -4.36. In the year 1983, what is the difference between the CO2 emissions (% of total fuel combustion) of High income: nonOECD and CO2 emissions (% of total fuel combustion) of Portugal?
Your answer should be compact. -2.21. In the year 1983, what is the difference between the CO2 emissions (% of total fuel combustion) in Colombia and CO2 emissions (% of total fuel combustion) in Iran?
Keep it short and to the point. -3.48. In the year 1983, what is the difference between the CO2 emissions (% of total fuel combustion) in Colombia and CO2 emissions (% of total fuel combustion) in Portugal?
Provide a short and direct response. -1.33. In the year 1983, what is the difference between the CO2 emissions (% of total fuel combustion) in Iran and CO2 emissions (% of total fuel combustion) in Portugal?
Provide a succinct answer. 2.14. In the year 1984, what is the difference between the CO2 emissions (% of total fuel combustion) in High income: nonOECD and CO2 emissions (% of total fuel combustion) in Colombia?
Your answer should be compact. -0.39. In the year 1984, what is the difference between the CO2 emissions (% of total fuel combustion) in High income: nonOECD and CO2 emissions (% of total fuel combustion) in Iran?
Give a very brief answer. -4.2. In the year 1984, what is the difference between the CO2 emissions (% of total fuel combustion) of High income: nonOECD and CO2 emissions (% of total fuel combustion) of Portugal?
Offer a terse response. -2.2. In the year 1984, what is the difference between the CO2 emissions (% of total fuel combustion) in Colombia and CO2 emissions (% of total fuel combustion) in Iran?
Give a very brief answer. -3.81. In the year 1984, what is the difference between the CO2 emissions (% of total fuel combustion) of Colombia and CO2 emissions (% of total fuel combustion) of Portugal?
Make the answer very short. -1.82. In the year 1984, what is the difference between the CO2 emissions (% of total fuel combustion) of Iran and CO2 emissions (% of total fuel combustion) of Portugal?
Offer a very short reply. 2. In the year 1985, what is the difference between the CO2 emissions (% of total fuel combustion) in High income: nonOECD and CO2 emissions (% of total fuel combustion) in Colombia?
Your response must be concise. -0.1. In the year 1985, what is the difference between the CO2 emissions (% of total fuel combustion) in High income: nonOECD and CO2 emissions (% of total fuel combustion) in Iran?
Keep it short and to the point. -4.28. In the year 1985, what is the difference between the CO2 emissions (% of total fuel combustion) in High income: nonOECD and CO2 emissions (% of total fuel combustion) in Portugal?
Your response must be concise. -2.38. In the year 1985, what is the difference between the CO2 emissions (% of total fuel combustion) of Colombia and CO2 emissions (% of total fuel combustion) of Iran?
Your answer should be very brief. -4.18. In the year 1985, what is the difference between the CO2 emissions (% of total fuel combustion) of Colombia and CO2 emissions (% of total fuel combustion) of Portugal?
Provide a succinct answer. -2.28. In the year 1985, what is the difference between the CO2 emissions (% of total fuel combustion) in Iran and CO2 emissions (% of total fuel combustion) in Portugal?
Offer a terse response. 1.91. In the year 1986, what is the difference between the CO2 emissions (% of total fuel combustion) in High income: nonOECD and CO2 emissions (% of total fuel combustion) in Colombia?
Provide a short and direct response. -0.29. In the year 1986, what is the difference between the CO2 emissions (% of total fuel combustion) of High income: nonOECD and CO2 emissions (% of total fuel combustion) of Iran?
Your response must be concise. -4.8. In the year 1986, what is the difference between the CO2 emissions (% of total fuel combustion) of High income: nonOECD and CO2 emissions (% of total fuel combustion) of Portugal?
Offer a very short reply. -2.23. In the year 1986, what is the difference between the CO2 emissions (% of total fuel combustion) in Colombia and CO2 emissions (% of total fuel combustion) in Iran?
Your answer should be compact. -4.51. In the year 1986, what is the difference between the CO2 emissions (% of total fuel combustion) of Colombia and CO2 emissions (% of total fuel combustion) of Portugal?
Your answer should be very brief. -1.94. In the year 1986, what is the difference between the CO2 emissions (% of total fuel combustion) of Iran and CO2 emissions (% of total fuel combustion) of Portugal?
Ensure brevity in your answer.  2.57. In the year 1987, what is the difference between the CO2 emissions (% of total fuel combustion) in High income: nonOECD and CO2 emissions (% of total fuel combustion) in Colombia?
Keep it short and to the point. -2.24. In the year 1987, what is the difference between the CO2 emissions (% of total fuel combustion) in High income: nonOECD and CO2 emissions (% of total fuel combustion) in Iran?
Offer a very short reply. -4.48. In the year 1987, what is the difference between the CO2 emissions (% of total fuel combustion) of High income: nonOECD and CO2 emissions (% of total fuel combustion) of Portugal?
Ensure brevity in your answer.  -1.59. In the year 1987, what is the difference between the CO2 emissions (% of total fuel combustion) in Colombia and CO2 emissions (% of total fuel combustion) in Iran?
Offer a very short reply. -2.24. In the year 1987, what is the difference between the CO2 emissions (% of total fuel combustion) of Colombia and CO2 emissions (% of total fuel combustion) of Portugal?
Your answer should be compact. 0.65. In the year 1987, what is the difference between the CO2 emissions (% of total fuel combustion) of Iran and CO2 emissions (% of total fuel combustion) of Portugal?
Make the answer very short. 2.88. In the year 1988, what is the difference between the CO2 emissions (% of total fuel combustion) of High income: nonOECD and CO2 emissions (% of total fuel combustion) of Colombia?
Keep it short and to the point. -1.22. In the year 1988, what is the difference between the CO2 emissions (% of total fuel combustion) in High income: nonOECD and CO2 emissions (% of total fuel combustion) in Iran?
Give a very brief answer. -4.45. In the year 1988, what is the difference between the CO2 emissions (% of total fuel combustion) of High income: nonOECD and CO2 emissions (% of total fuel combustion) of Portugal?
Provide a short and direct response. -1.25. In the year 1988, what is the difference between the CO2 emissions (% of total fuel combustion) in Colombia and CO2 emissions (% of total fuel combustion) in Iran?
Make the answer very short. -3.23. In the year 1988, what is the difference between the CO2 emissions (% of total fuel combustion) of Colombia and CO2 emissions (% of total fuel combustion) of Portugal?
Ensure brevity in your answer.  -0.03. In the year 1988, what is the difference between the CO2 emissions (% of total fuel combustion) of Iran and CO2 emissions (% of total fuel combustion) of Portugal?
Offer a very short reply. 3.19. What is the ratio of the CO2 emissions (% of total fuel combustion) of Colombia in 1982 to that in 1983?
Offer a very short reply. 1.22. What is the ratio of the CO2 emissions (% of total fuel combustion) in Portugal in 1982 to that in 1983?
Your answer should be very brief. 0.9. What is the ratio of the CO2 emissions (% of total fuel combustion) in High income: nonOECD in 1982 to that in 1984?
Your answer should be compact. 0.98. What is the ratio of the CO2 emissions (% of total fuel combustion) in Colombia in 1982 to that in 1984?
Make the answer very short. 1.42. What is the ratio of the CO2 emissions (% of total fuel combustion) of Portugal in 1982 to that in 1984?
Ensure brevity in your answer.  0.9. What is the ratio of the CO2 emissions (% of total fuel combustion) of High income: nonOECD in 1982 to that in 1985?
Your response must be concise. 0.87. What is the ratio of the CO2 emissions (% of total fuel combustion) of Colombia in 1982 to that in 1985?
Make the answer very short. 1.42. What is the ratio of the CO2 emissions (% of total fuel combustion) in Iran in 1982 to that in 1985?
Give a very brief answer. 0.96. What is the ratio of the CO2 emissions (% of total fuel combustion) in Portugal in 1982 to that in 1985?
Offer a terse response. 0.82. What is the ratio of the CO2 emissions (% of total fuel combustion) in High income: nonOECD in 1982 to that in 1986?
Offer a very short reply. 1.01. What is the ratio of the CO2 emissions (% of total fuel combustion) of Colombia in 1982 to that in 1986?
Keep it short and to the point. 1.52. What is the ratio of the CO2 emissions (% of total fuel combustion) in Iran in 1982 to that in 1986?
Ensure brevity in your answer.  0.94. What is the ratio of the CO2 emissions (% of total fuel combustion) of Portugal in 1982 to that in 1986?
Your response must be concise. 0.91. What is the ratio of the CO2 emissions (% of total fuel combustion) of High income: nonOECD in 1982 to that in 1987?
Make the answer very short. 0.86. What is the ratio of the CO2 emissions (% of total fuel combustion) in Colombia in 1982 to that in 1987?
Provide a short and direct response. 0.79. What is the ratio of the CO2 emissions (% of total fuel combustion) in Iran in 1982 to that in 1987?
Make the answer very short. 0.92. What is the ratio of the CO2 emissions (% of total fuel combustion) in Portugal in 1982 to that in 1987?
Make the answer very short. 0.95. What is the ratio of the CO2 emissions (% of total fuel combustion) in High income: nonOECD in 1982 to that in 1988?
Your answer should be compact. 0.78. What is the ratio of the CO2 emissions (% of total fuel combustion) in Colombia in 1982 to that in 1988?
Your response must be concise. 0.93. What is the ratio of the CO2 emissions (% of total fuel combustion) of Iran in 1982 to that in 1988?
Keep it short and to the point. 0.89. What is the ratio of the CO2 emissions (% of total fuel combustion) in Portugal in 1982 to that in 1988?
Give a very brief answer. 0.97. What is the ratio of the CO2 emissions (% of total fuel combustion) of High income: nonOECD in 1983 to that in 1984?
Offer a very short reply. 0.98. What is the ratio of the CO2 emissions (% of total fuel combustion) of Colombia in 1983 to that in 1984?
Give a very brief answer. 1.16. What is the ratio of the CO2 emissions (% of total fuel combustion) in Iran in 1983 to that in 1984?
Provide a succinct answer. 1.02. What is the ratio of the CO2 emissions (% of total fuel combustion) in Portugal in 1983 to that in 1984?
Make the answer very short. 0.99. What is the ratio of the CO2 emissions (% of total fuel combustion) of Colombia in 1983 to that in 1985?
Ensure brevity in your answer.  1.17. What is the ratio of the CO2 emissions (% of total fuel combustion) of Iran in 1983 to that in 1985?
Your answer should be very brief. 0.96. What is the ratio of the CO2 emissions (% of total fuel combustion) in Portugal in 1983 to that in 1985?
Give a very brief answer. 0.9. What is the ratio of the CO2 emissions (% of total fuel combustion) of High income: nonOECD in 1983 to that in 1986?
Provide a succinct answer. 1.02. What is the ratio of the CO2 emissions (% of total fuel combustion) of Colombia in 1983 to that in 1986?
Give a very brief answer. 1.24. What is the ratio of the CO2 emissions (% of total fuel combustion) in Iran in 1983 to that in 1986?
Give a very brief answer. 0.94. What is the ratio of the CO2 emissions (% of total fuel combustion) of High income: nonOECD in 1983 to that in 1987?
Give a very brief answer. 0.86. What is the ratio of the CO2 emissions (% of total fuel combustion) of Colombia in 1983 to that in 1987?
Your response must be concise. 0.65. What is the ratio of the CO2 emissions (% of total fuel combustion) of Iran in 1983 to that in 1987?
Your answer should be compact. 0.93. What is the ratio of the CO2 emissions (% of total fuel combustion) in Portugal in 1983 to that in 1987?
Ensure brevity in your answer.  1.06. What is the ratio of the CO2 emissions (% of total fuel combustion) in High income: nonOECD in 1983 to that in 1988?
Your answer should be very brief. 0.79. What is the ratio of the CO2 emissions (% of total fuel combustion) of Colombia in 1983 to that in 1988?
Make the answer very short. 0.77. What is the ratio of the CO2 emissions (% of total fuel combustion) in Iran in 1983 to that in 1988?
Provide a short and direct response. 0.9. What is the ratio of the CO2 emissions (% of total fuel combustion) in Portugal in 1983 to that in 1988?
Give a very brief answer. 1.08. What is the ratio of the CO2 emissions (% of total fuel combustion) in High income: nonOECD in 1984 to that in 1985?
Your answer should be compact. 0.9. What is the ratio of the CO2 emissions (% of total fuel combustion) in Iran in 1984 to that in 1985?
Provide a succinct answer. 0.95. What is the ratio of the CO2 emissions (% of total fuel combustion) in Portugal in 1984 to that in 1985?
Give a very brief answer. 0.91. What is the ratio of the CO2 emissions (% of total fuel combustion) in High income: nonOECD in 1984 to that in 1986?
Give a very brief answer. 1.04. What is the ratio of the CO2 emissions (% of total fuel combustion) in Colombia in 1984 to that in 1986?
Offer a very short reply. 1.07. What is the ratio of the CO2 emissions (% of total fuel combustion) in Iran in 1984 to that in 1986?
Your response must be concise. 0.93. What is the ratio of the CO2 emissions (% of total fuel combustion) in Portugal in 1984 to that in 1986?
Offer a very short reply. 1.01. What is the ratio of the CO2 emissions (% of total fuel combustion) in High income: nonOECD in 1984 to that in 1987?
Offer a very short reply. 0.88. What is the ratio of the CO2 emissions (% of total fuel combustion) of Colombia in 1984 to that in 1987?
Ensure brevity in your answer.  0.56. What is the ratio of the CO2 emissions (% of total fuel combustion) in Iran in 1984 to that in 1987?
Make the answer very short. 0.92. What is the ratio of the CO2 emissions (% of total fuel combustion) in Portugal in 1984 to that in 1987?
Provide a succinct answer. 1.06. What is the ratio of the CO2 emissions (% of total fuel combustion) of High income: nonOECD in 1984 to that in 1988?
Your response must be concise. 0.8. What is the ratio of the CO2 emissions (% of total fuel combustion) of Colombia in 1984 to that in 1988?
Your response must be concise. 0.66. What is the ratio of the CO2 emissions (% of total fuel combustion) of Iran in 1984 to that in 1988?
Ensure brevity in your answer.  0.89. What is the ratio of the CO2 emissions (% of total fuel combustion) of Portugal in 1984 to that in 1988?
Your answer should be compact. 1.08. What is the ratio of the CO2 emissions (% of total fuel combustion) in High income: nonOECD in 1985 to that in 1986?
Give a very brief answer. 1.16. What is the ratio of the CO2 emissions (% of total fuel combustion) of Colombia in 1985 to that in 1986?
Offer a very short reply. 1.07. What is the ratio of the CO2 emissions (% of total fuel combustion) of Iran in 1985 to that in 1986?
Make the answer very short. 0.98. What is the ratio of the CO2 emissions (% of total fuel combustion) in Portugal in 1985 to that in 1986?
Provide a short and direct response. 1.11. What is the ratio of the CO2 emissions (% of total fuel combustion) in High income: nonOECD in 1985 to that in 1987?
Your answer should be compact. 0.98. What is the ratio of the CO2 emissions (% of total fuel combustion) in Colombia in 1985 to that in 1987?
Provide a short and direct response. 0.56. What is the ratio of the CO2 emissions (% of total fuel combustion) in Iran in 1985 to that in 1987?
Offer a terse response. 0.97. What is the ratio of the CO2 emissions (% of total fuel combustion) in Portugal in 1985 to that in 1987?
Keep it short and to the point. 1.17. What is the ratio of the CO2 emissions (% of total fuel combustion) in High income: nonOECD in 1985 to that in 1988?
Your response must be concise. 0.89. What is the ratio of the CO2 emissions (% of total fuel combustion) of Colombia in 1985 to that in 1988?
Provide a short and direct response. 0.66. What is the ratio of the CO2 emissions (% of total fuel combustion) in Iran in 1985 to that in 1988?
Offer a terse response. 0.94. What is the ratio of the CO2 emissions (% of total fuel combustion) in Portugal in 1985 to that in 1988?
Offer a terse response. 1.19. What is the ratio of the CO2 emissions (% of total fuel combustion) in High income: nonOECD in 1986 to that in 1987?
Offer a very short reply. 0.85. What is the ratio of the CO2 emissions (% of total fuel combustion) of Colombia in 1986 to that in 1987?
Make the answer very short. 0.52. What is the ratio of the CO2 emissions (% of total fuel combustion) in Iran in 1986 to that in 1987?
Your answer should be very brief. 0.99. What is the ratio of the CO2 emissions (% of total fuel combustion) of Portugal in 1986 to that in 1987?
Offer a very short reply. 1.05. What is the ratio of the CO2 emissions (% of total fuel combustion) of High income: nonOECD in 1986 to that in 1988?
Ensure brevity in your answer.  0.77. What is the ratio of the CO2 emissions (% of total fuel combustion) in Colombia in 1986 to that in 1988?
Give a very brief answer. 0.62. What is the ratio of the CO2 emissions (% of total fuel combustion) of Iran in 1986 to that in 1988?
Your response must be concise. 0.96. What is the ratio of the CO2 emissions (% of total fuel combustion) of Portugal in 1986 to that in 1988?
Your answer should be very brief. 1.07. What is the ratio of the CO2 emissions (% of total fuel combustion) in High income: nonOECD in 1987 to that in 1988?
Offer a terse response. 0.91. What is the ratio of the CO2 emissions (% of total fuel combustion) of Colombia in 1987 to that in 1988?
Keep it short and to the point. 1.18. What is the ratio of the CO2 emissions (% of total fuel combustion) of Iran in 1987 to that in 1988?
Offer a terse response. 0.97. What is the ratio of the CO2 emissions (% of total fuel combustion) in Portugal in 1987 to that in 1988?
Your answer should be compact. 1.02. What is the difference between the highest and the second highest CO2 emissions (% of total fuel combustion) of High income: nonOECD?
Provide a short and direct response. 0.26. What is the difference between the highest and the second highest CO2 emissions (% of total fuel combustion) of Colombia?
Keep it short and to the point. 0.76. What is the difference between the highest and the second highest CO2 emissions (% of total fuel combustion) in Iran?
Offer a terse response. 0.23. What is the difference between the highest and the second highest CO2 emissions (% of total fuel combustion) in Portugal?
Offer a very short reply. 0.45. What is the difference between the highest and the lowest CO2 emissions (% of total fuel combustion) of High income: nonOECD?
Provide a succinct answer. 0.68. What is the difference between the highest and the lowest CO2 emissions (% of total fuel combustion) of Colombia?
Offer a terse response. 2.37. What is the difference between the highest and the lowest CO2 emissions (% of total fuel combustion) in Iran?
Provide a succinct answer. 0.84. What is the difference between the highest and the lowest CO2 emissions (% of total fuel combustion) in Portugal?
Your response must be concise. 0.93. 